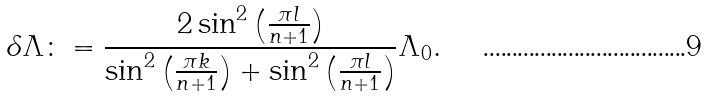Convert formula to latex. <formula><loc_0><loc_0><loc_500><loc_500>\delta \Lambda \colon = \frac { 2 \sin ^ { 2 } \left ( \frac { \pi l } { n + 1 } \right ) } { \sin ^ { 2 } \left ( \frac { \pi k } { n + 1 } \right ) + \sin ^ { 2 } \left ( \frac { \pi l } { n + 1 } \right ) } \Lambda _ { 0 } .</formula> 